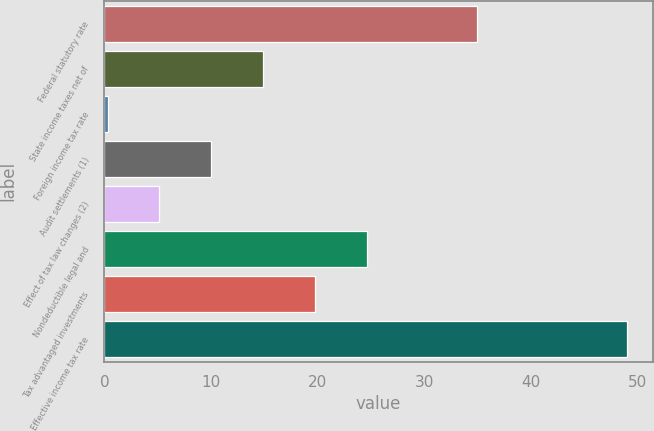Convert chart to OTSL. <chart><loc_0><loc_0><loc_500><loc_500><bar_chart><fcel>Federal statutory rate<fcel>State income taxes net of<fcel>Foreign income tax rate<fcel>Audit settlements (1)<fcel>Effect of tax law changes (2)<fcel>Nondeductible legal and<fcel>Tax advantaged investments<fcel>Effective income tax rate<nl><fcel>35<fcel>14.91<fcel>0.3<fcel>10.04<fcel>5.17<fcel>24.65<fcel>19.78<fcel>49<nl></chart> 